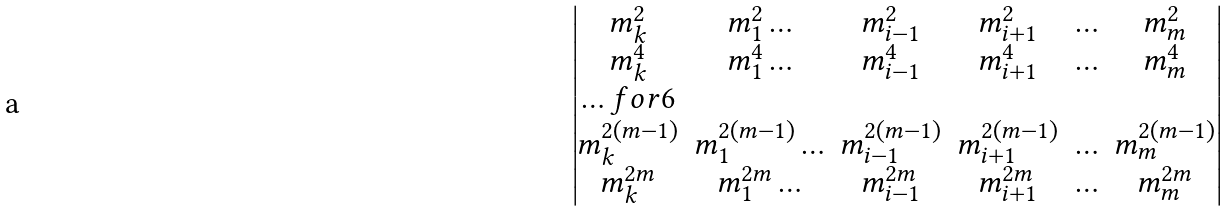Convert formula to latex. <formula><loc_0><loc_0><loc_500><loc_500>\begin{vmatrix} m _ { k } ^ { 2 } & m _ { 1 } ^ { 2 } \hdots & m _ { i - 1 } ^ { 2 } & m _ { i + 1 } ^ { 2 } & \hdots & m _ { m } ^ { 2 } \\ m _ { k } ^ { 4 } & m _ { 1 } ^ { 4 } \hdots & m _ { i - 1 } ^ { 4 } & m _ { i + 1 } ^ { 4 } & \hdots & m _ { m } ^ { 4 } \\ \hdots f o r 6 \\ m _ { k } ^ { 2 ( m - 1 ) } & m _ { 1 } ^ { 2 ( m - 1 ) } \hdots & m _ { i - 1 } ^ { 2 ( m - 1 ) } & m _ { i + 1 } ^ { 2 ( m - 1 ) } & \hdots & m _ { m } ^ { 2 ( m - 1 ) } \\ m _ { k } ^ { 2 m } & m _ { 1 } ^ { 2 m } \hdots & m _ { i - 1 } ^ { 2 m } & m _ { i + 1 } ^ { 2 m } & \hdots & m _ { m } ^ { 2 m } \\ \end{vmatrix}</formula> 